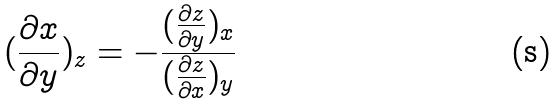<formula> <loc_0><loc_0><loc_500><loc_500>( \frac { \partial x } { \partial y } ) _ { z } = - \frac { ( \frac { \partial z } { \partial y } ) _ { x } } { ( \frac { \partial z } { \partial x } ) _ { y } }</formula> 